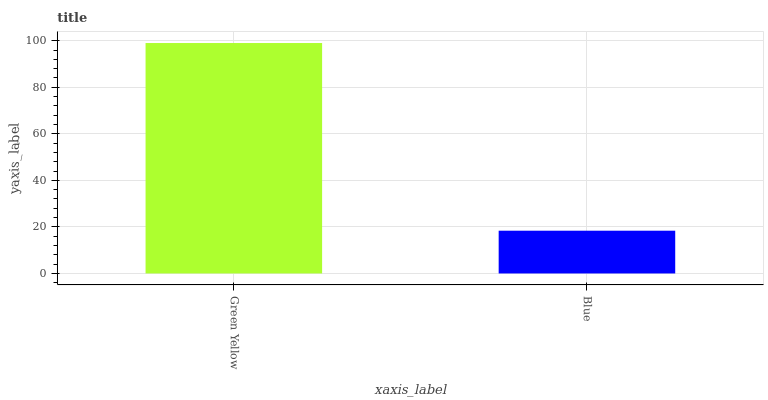Is Blue the minimum?
Answer yes or no. Yes. Is Green Yellow the maximum?
Answer yes or no. Yes. Is Blue the maximum?
Answer yes or no. No. Is Green Yellow greater than Blue?
Answer yes or no. Yes. Is Blue less than Green Yellow?
Answer yes or no. Yes. Is Blue greater than Green Yellow?
Answer yes or no. No. Is Green Yellow less than Blue?
Answer yes or no. No. Is Green Yellow the high median?
Answer yes or no. Yes. Is Blue the low median?
Answer yes or no. Yes. Is Blue the high median?
Answer yes or no. No. Is Green Yellow the low median?
Answer yes or no. No. 